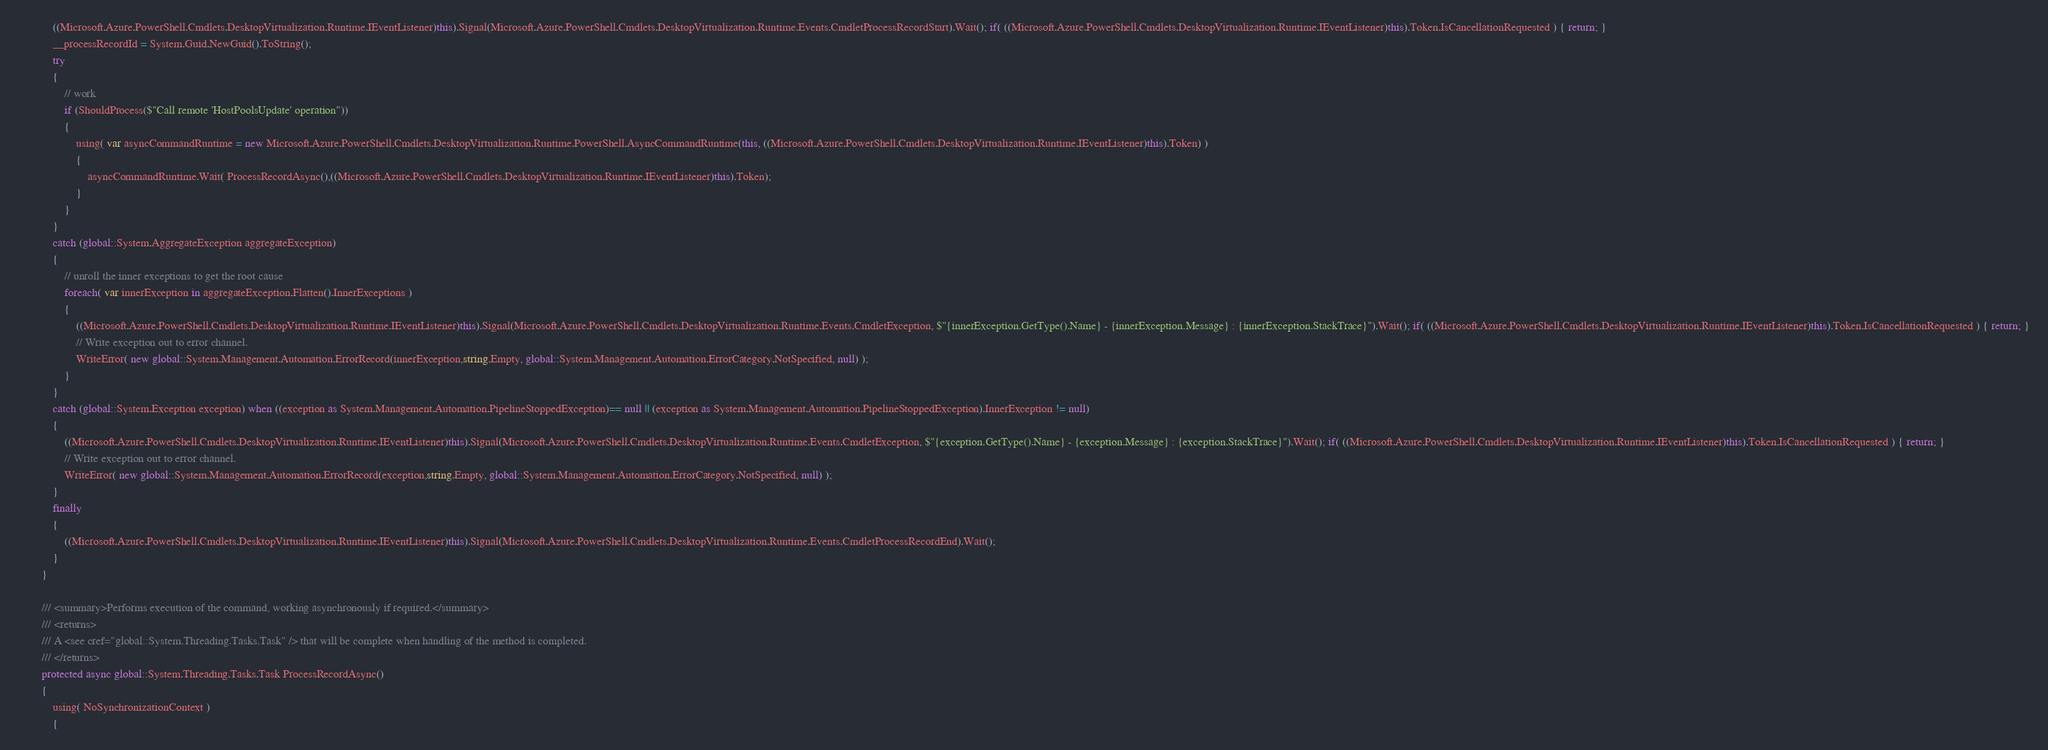Convert code to text. <code><loc_0><loc_0><loc_500><loc_500><_C#_>            ((Microsoft.Azure.PowerShell.Cmdlets.DesktopVirtualization.Runtime.IEventListener)this).Signal(Microsoft.Azure.PowerShell.Cmdlets.DesktopVirtualization.Runtime.Events.CmdletProcessRecordStart).Wait(); if( ((Microsoft.Azure.PowerShell.Cmdlets.DesktopVirtualization.Runtime.IEventListener)this).Token.IsCancellationRequested ) { return; }
            __processRecordId = System.Guid.NewGuid().ToString();
            try
            {
                // work
                if (ShouldProcess($"Call remote 'HostPoolsUpdate' operation"))
                {
                    using( var asyncCommandRuntime = new Microsoft.Azure.PowerShell.Cmdlets.DesktopVirtualization.Runtime.PowerShell.AsyncCommandRuntime(this, ((Microsoft.Azure.PowerShell.Cmdlets.DesktopVirtualization.Runtime.IEventListener)this).Token) )
                    {
                        asyncCommandRuntime.Wait( ProcessRecordAsync(),((Microsoft.Azure.PowerShell.Cmdlets.DesktopVirtualization.Runtime.IEventListener)this).Token);
                    }
                }
            }
            catch (global::System.AggregateException aggregateException)
            {
                // unroll the inner exceptions to get the root cause
                foreach( var innerException in aggregateException.Flatten().InnerExceptions )
                {
                    ((Microsoft.Azure.PowerShell.Cmdlets.DesktopVirtualization.Runtime.IEventListener)this).Signal(Microsoft.Azure.PowerShell.Cmdlets.DesktopVirtualization.Runtime.Events.CmdletException, $"{innerException.GetType().Name} - {innerException.Message} : {innerException.StackTrace}").Wait(); if( ((Microsoft.Azure.PowerShell.Cmdlets.DesktopVirtualization.Runtime.IEventListener)this).Token.IsCancellationRequested ) { return; }
                    // Write exception out to error channel.
                    WriteError( new global::System.Management.Automation.ErrorRecord(innerException,string.Empty, global::System.Management.Automation.ErrorCategory.NotSpecified, null) );
                }
            }
            catch (global::System.Exception exception) when ((exception as System.Management.Automation.PipelineStoppedException)== null || (exception as System.Management.Automation.PipelineStoppedException).InnerException != null)
            {
                ((Microsoft.Azure.PowerShell.Cmdlets.DesktopVirtualization.Runtime.IEventListener)this).Signal(Microsoft.Azure.PowerShell.Cmdlets.DesktopVirtualization.Runtime.Events.CmdletException, $"{exception.GetType().Name} - {exception.Message} : {exception.StackTrace}").Wait(); if( ((Microsoft.Azure.PowerShell.Cmdlets.DesktopVirtualization.Runtime.IEventListener)this).Token.IsCancellationRequested ) { return; }
                // Write exception out to error channel.
                WriteError( new global::System.Management.Automation.ErrorRecord(exception,string.Empty, global::System.Management.Automation.ErrorCategory.NotSpecified, null) );
            }
            finally
            {
                ((Microsoft.Azure.PowerShell.Cmdlets.DesktopVirtualization.Runtime.IEventListener)this).Signal(Microsoft.Azure.PowerShell.Cmdlets.DesktopVirtualization.Runtime.Events.CmdletProcessRecordEnd).Wait();
            }
        }

        /// <summary>Performs execution of the command, working asynchronously if required.</summary>
        /// <returns>
        /// A <see cref="global::System.Threading.Tasks.Task" /> that will be complete when handling of the method is completed.
        /// </returns>
        protected async global::System.Threading.Tasks.Task ProcessRecordAsync()
        {
            using( NoSynchronizationContext )
            {</code> 